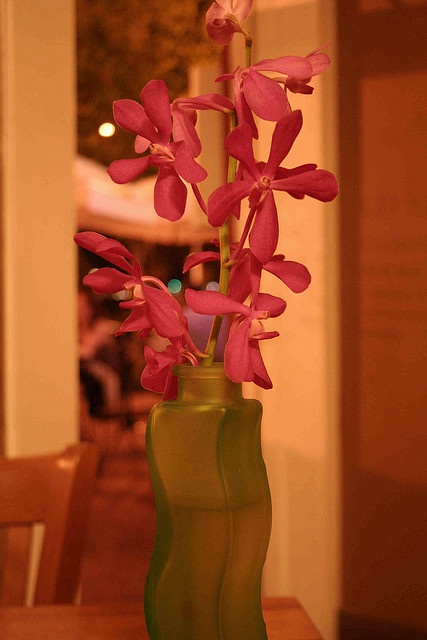Describe the objects in this image and their specific colors. I can see vase in orange and maroon tones, chair in orange, maroon, brown, and red tones, and dining table in orange, brown, maroon, and red tones in this image. 